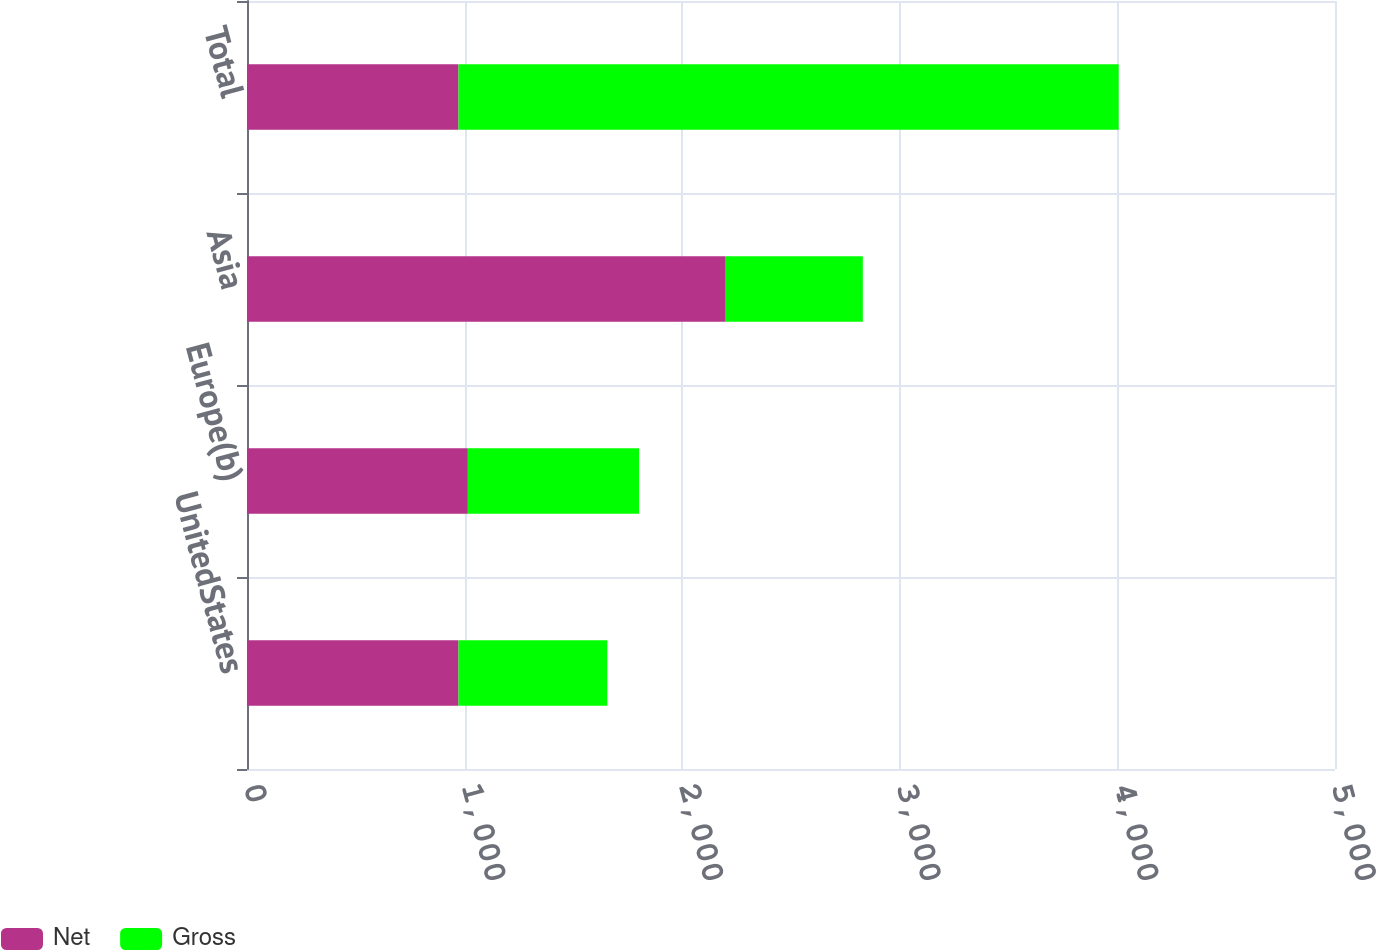<chart> <loc_0><loc_0><loc_500><loc_500><stacked_bar_chart><ecel><fcel>UnitedStates<fcel>Europe(b)<fcel>Asia<fcel>Total<nl><fcel>Net<fcel>972<fcel>1015<fcel>2200<fcel>972<nl><fcel>Gross<fcel>684<fcel>787<fcel>630<fcel>3034<nl></chart> 